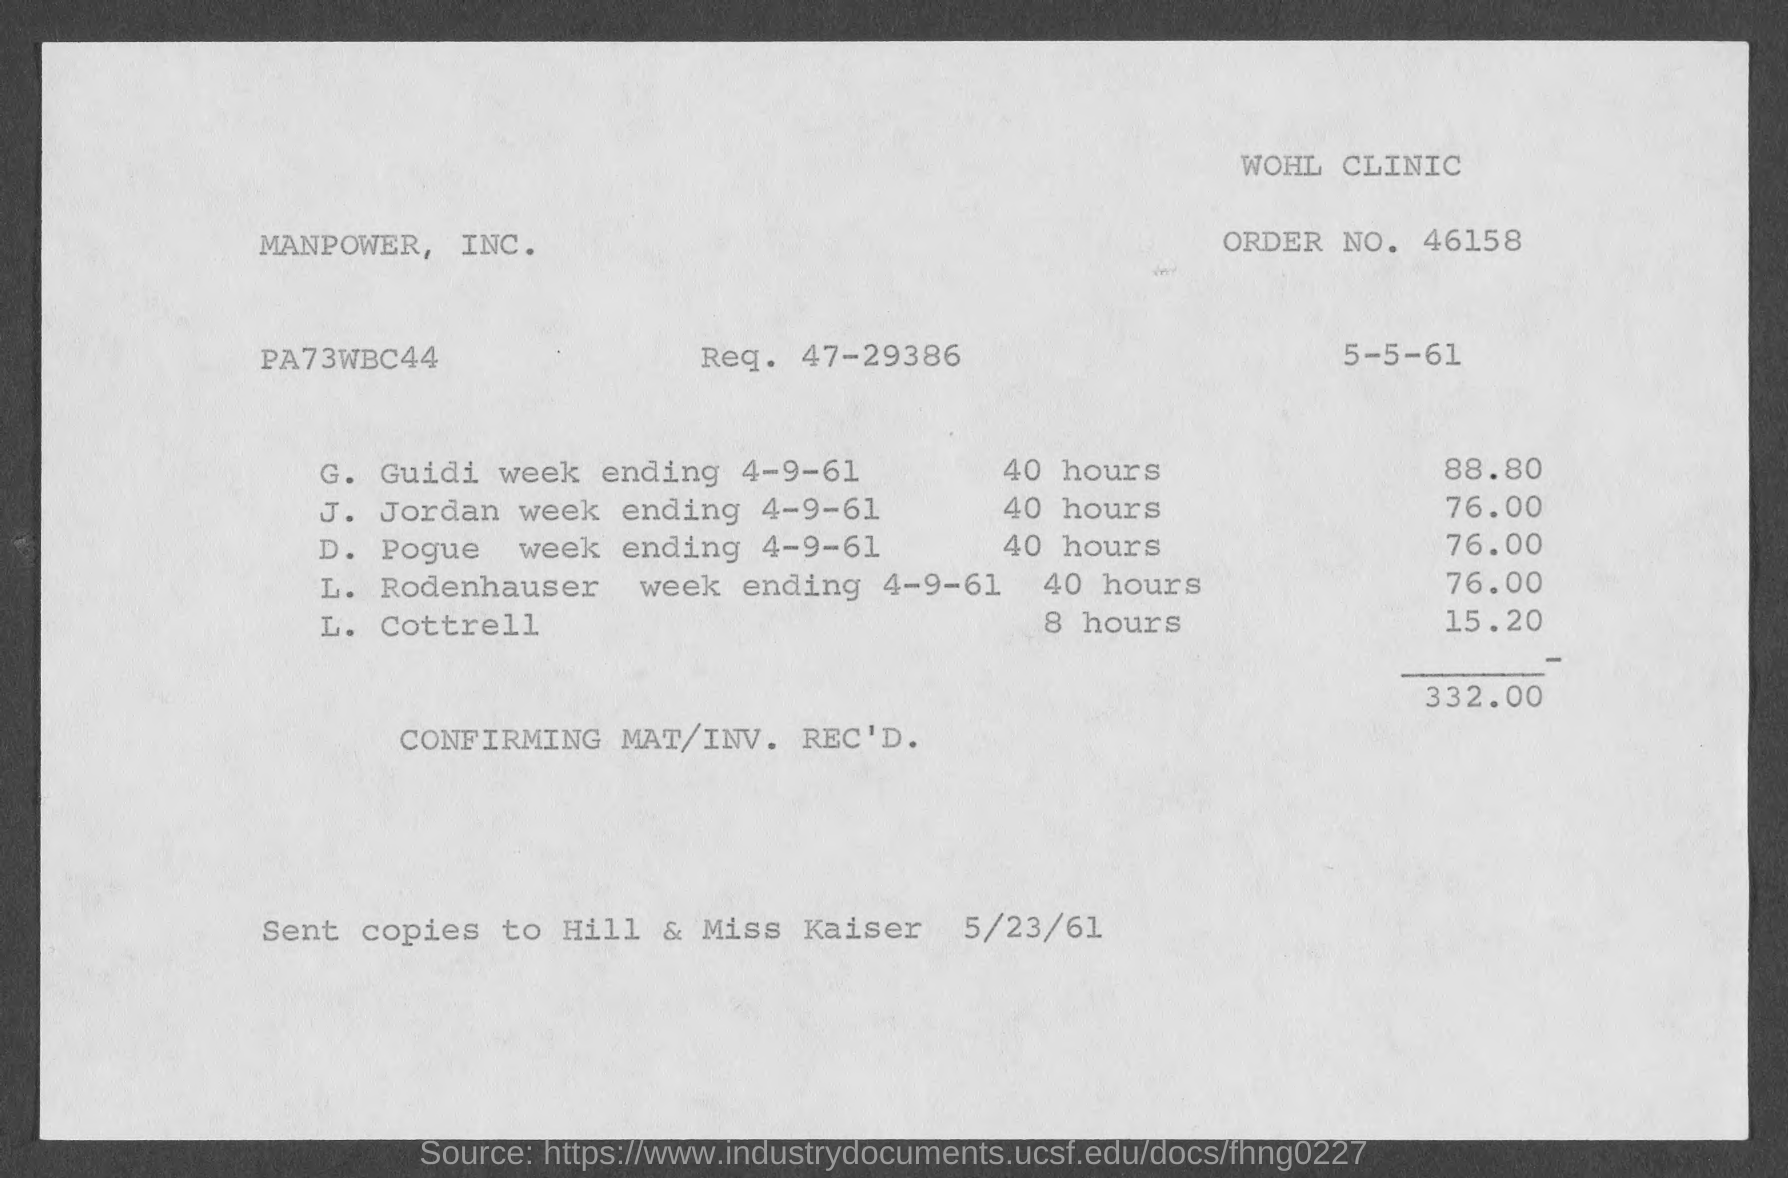Give some essential details in this illustration. The name of the clinic is the WOHL clinic. What is the number? 47-29386... 